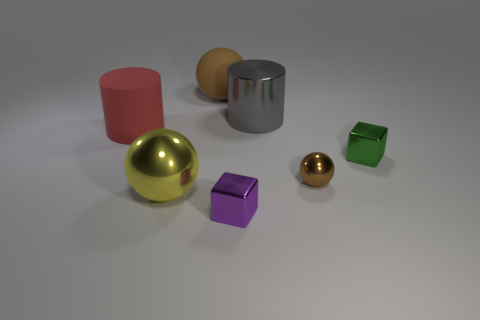Subtract all brown balls. How many were subtracted if there are1brown balls left? 1 Add 3 metal blocks. How many objects exist? 10 Subtract all cubes. How many objects are left? 5 Add 2 cylinders. How many cylinders exist? 4 Subtract 0 green cylinders. How many objects are left? 7 Subtract all large gray matte balls. Subtract all metallic cylinders. How many objects are left? 6 Add 3 red matte things. How many red matte things are left? 4 